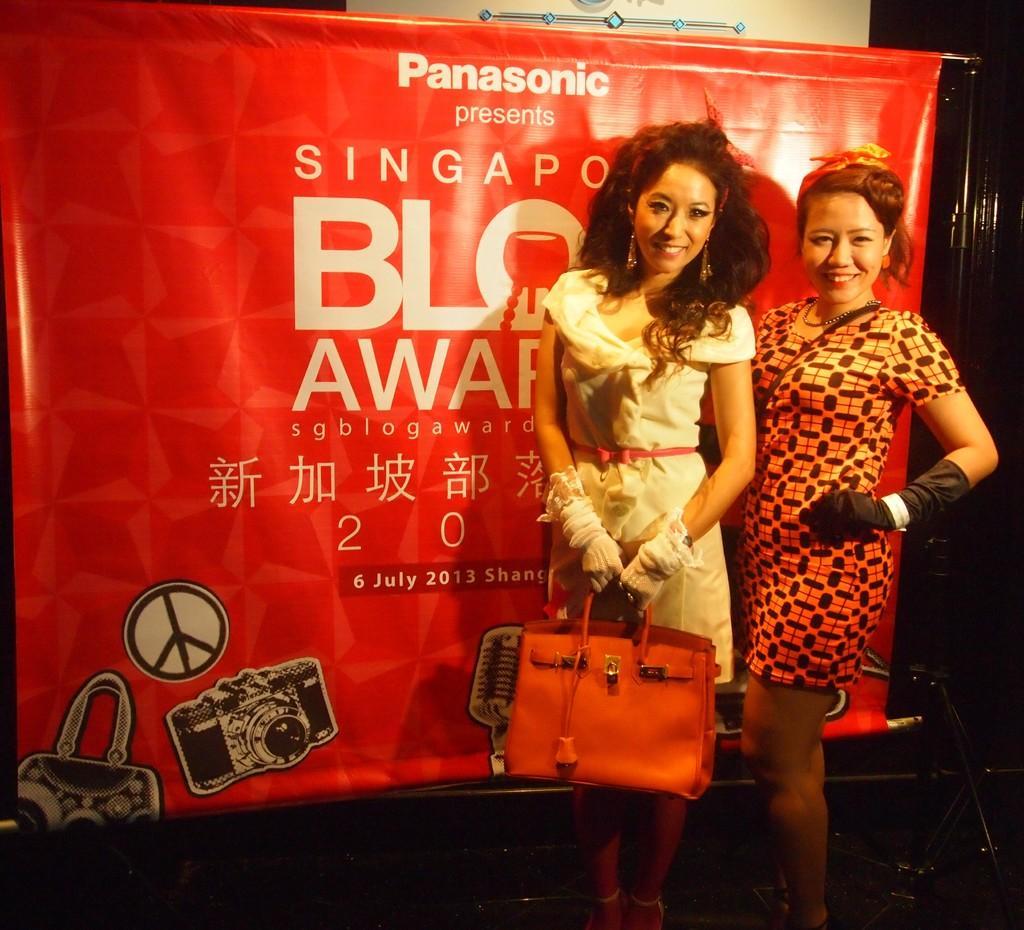How would you summarize this image in a sentence or two? In this image, In the right side there are two person standing and in the background there is a red color poster. 